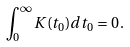Convert formula to latex. <formula><loc_0><loc_0><loc_500><loc_500>\int _ { 0 } ^ { \infty } K ( t _ { 0 } ) d t _ { 0 } = 0 \, .</formula> 